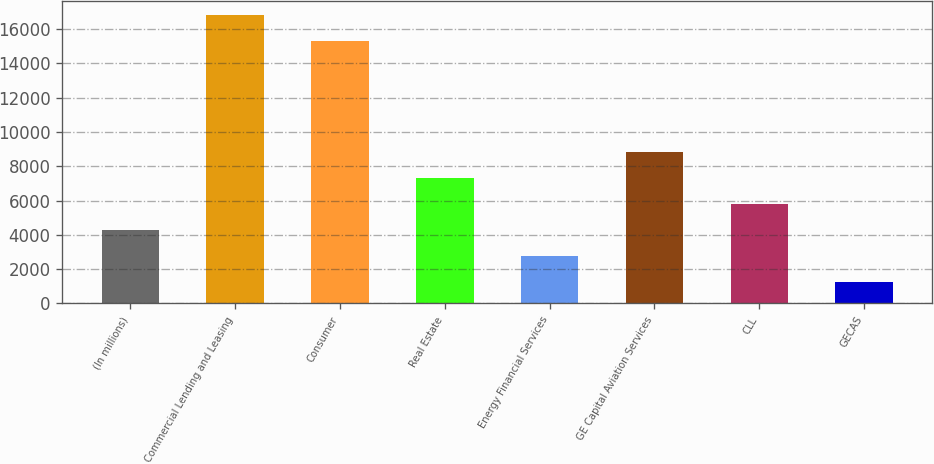Convert chart to OTSL. <chart><loc_0><loc_0><loc_500><loc_500><bar_chart><fcel>(In millions)<fcel>Commercial Lending and Leasing<fcel>Consumer<fcel>Real Estate<fcel>Energy Financial Services<fcel>GE Capital Aviation Services<fcel>CLL<fcel>GECAS<nl><fcel>4267.6<fcel>16826.8<fcel>15303<fcel>7315.2<fcel>2743.8<fcel>8839<fcel>5791.4<fcel>1220<nl></chart> 